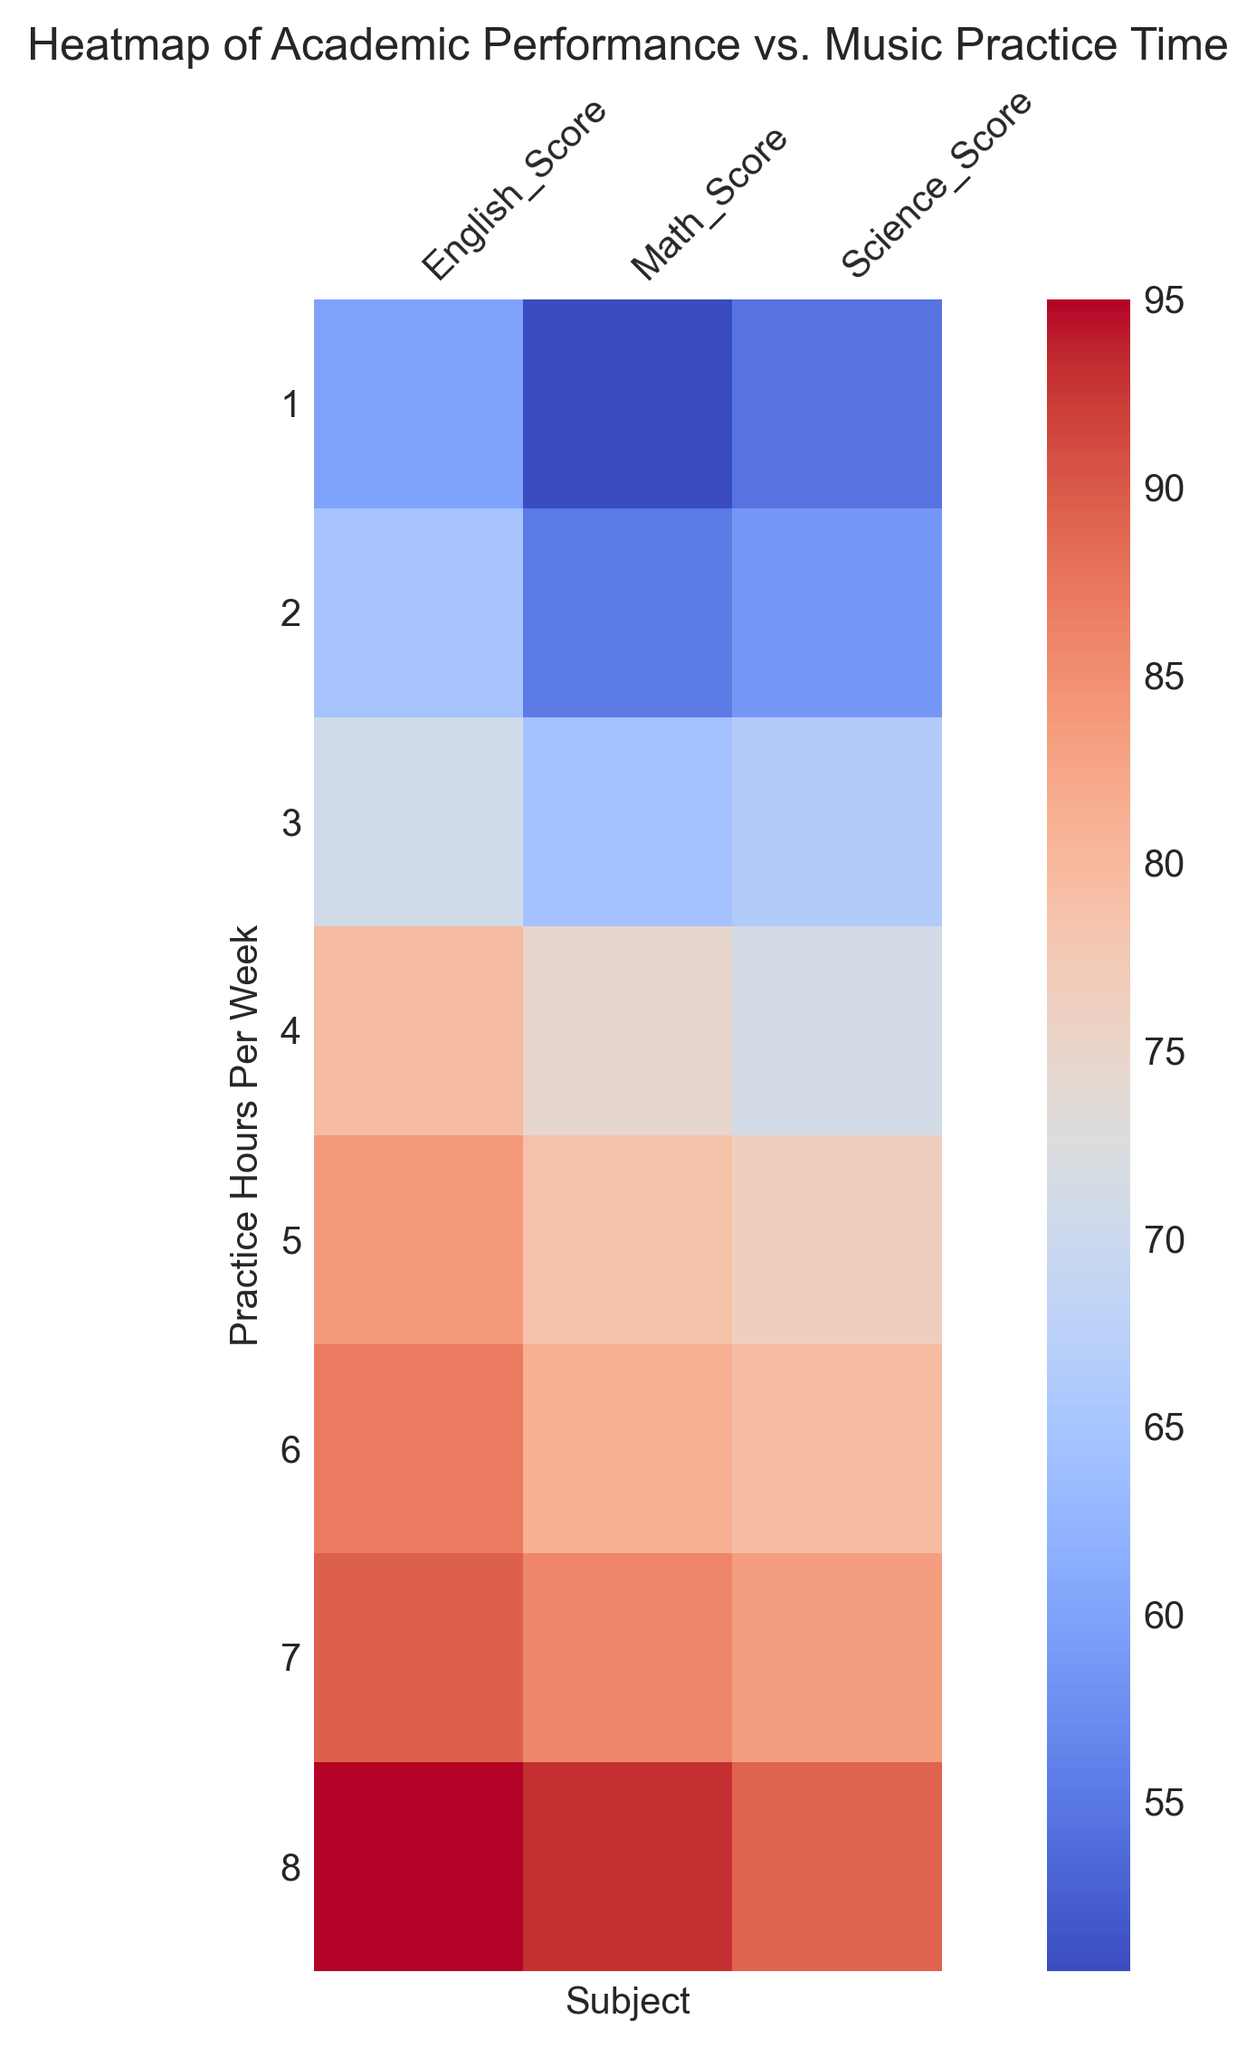Which practice hours per week correspond to the highest average math score? Look at the y-axis to find the practice hours per week and on the x-axis to find the Math_Score. Observe the color intensity. The darkest red color likely represents the highest value, which corresponds to 8 hours per week.
Answer: 8 hours per week Is there more variation in Science_Score or English_Score as practice hours increase? Compare the color gradient for Science_Score and English_Score across the different practice hours on the y-axis. Given the color differences, English_Score typically shows more variation compared to Science_Score.
Answer: English_Score At which practice hours does the average score in English seem to peak? By observing the color intensity at different practice hour levels for English_Score, the darkest shade which signifies the highest average score is at 8 hours per week.
Answer: 8 hours per week What is the overall trend observed between practice hours and academic performance in Math? Notice the color intensity for Math_Score across different practice hours. Generally, as practice hours increase, the shades intensify indicating an increase in Math_Score. The trend shows that more practice hours are associated with higher scores.
Answer: Positive trend How does the average Science_Score for 5 practice hours compare to that for 3 practice hours? Compare the color intensity for Science_Score at 5 hours and 3 hours of practice. The intensity at 5 hours is darker, indicating a higher average score compared to 3 hours.
Answer: Higher at 5 hours Between students practicing 2 hours and 4 hours per week, for which practice time is the average Math_Score higher? Compare the color shades for Math_Score at 2 hours and 4 hours of practice. The 4 hours section shows a darker shade indicating a higher score.
Answer: 4 hours What differences in trends can be seen between subjects as practice hours increase? Examine the color intensities for Math_Score, English_Score, and Science_Score as practice hours increase. The trend for Math and English lines consistently show darker shades indicating a positive trend, whereas Science_Score appears to have less pronounced variations as practice hours increase.
Answer: Math and English show a positive trend; Science less pronounced At 6 hours of practice, which subject has the closest average score to the one at 8 hours of practice? Compare the intensities at 6 hours for each subject and compare them to the 8 hours practice intensity. The colors for English_Score appear to be the closest in intensity.
Answer: English Which practice hour level shows the lowest average English_Score? Find the lightest color for English_Score across all practice hours. The lightest color occurs at 1 hour of practice.
Answer: 1 hour How does practice time correlate with performance in Science compared to Math? Observe the color intensities for both Math and Science Scores as practice hours increase. Math shows a more distinct positive trend with increasing intensity, while Science shows less drastic changes across the practice hours.
Answer: Stronger correlation for Math 